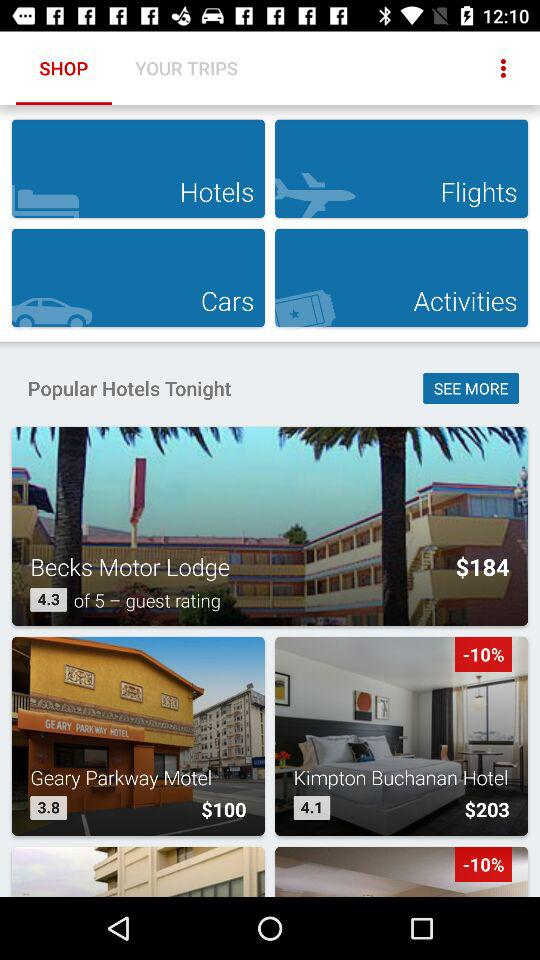What is the currency of the prices? The currency of the prices is $. 